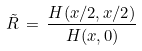<formula> <loc_0><loc_0><loc_500><loc_500>\tilde { R } \, = \, \frac { H ( x / 2 , x / 2 ) } { H ( x , 0 ) }</formula> 